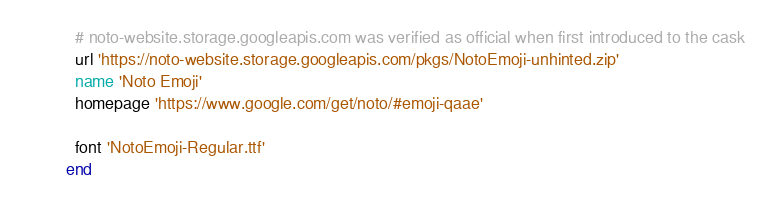<code> <loc_0><loc_0><loc_500><loc_500><_Ruby_>
  # noto-website.storage.googleapis.com was verified as official when first introduced to the cask
  url 'https://noto-website.storage.googleapis.com/pkgs/NotoEmoji-unhinted.zip'
  name 'Noto Emoji'
  homepage 'https://www.google.com/get/noto/#emoji-qaae'

  font 'NotoEmoji-Regular.ttf'
end
</code> 